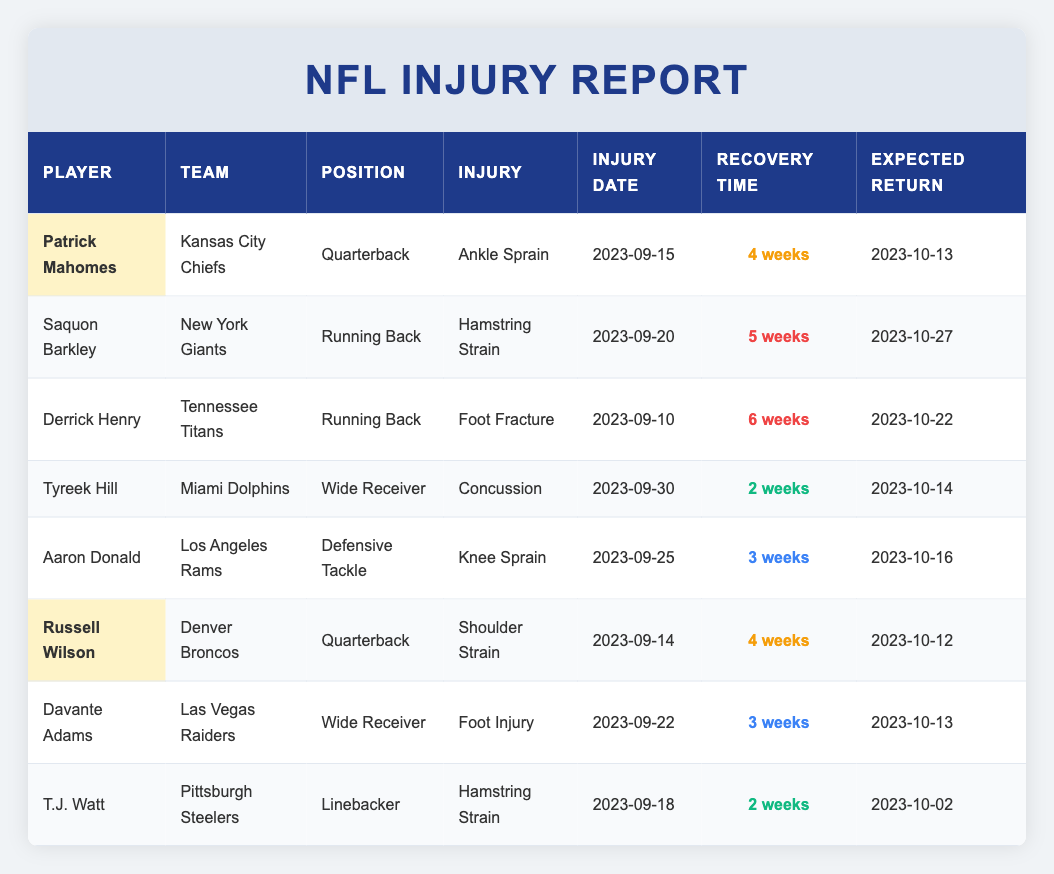What is the expected return date for Patrick Mahomes? The table shows that the expected return date for Patrick Mahomes, who has an ankle sprain, is listed as 2023-10-13.
Answer: 2023-10-13 Which player has the longest recovery timeline? Derrick Henry's recovery time is listed as 6 weeks, which is the longest compared to other players in the table.
Answer: Derrick Henry Are there any players expected to return in less than 3 weeks? Yes, Tyreek Hill and T.J. Watt are expected to return in 2 weeks, which is less than 3 weeks, as indicated in the recovery time column.
Answer: Yes How many players are quarterbacks and what are their recovery times? There are two quarterbacks: Patrick Mahomes with a recovery time of 4 weeks and Russell Wilson also with a recovery time of 4 weeks, as seen in their respective rows.
Answer: 2 players, 4 weeks each What injury did Saquon Barkley sustain, and when is he expected to return? The table indicates that Saquon Barkley sustained a hamstring strain and is expected to return on 2023-10-27, which can be found in his row.
Answer: Hamstring strain, 2023-10-27 Which player is expected to return first, and when? T.J. Watt is expected to return first on 2023-10-02, which is the earliest date listed in the expected return column.
Answer: T.J. Watt on 2023-10-02 Is there any player returning on the same day as Patrick Mahomes? Yes, Davante Adams is also expected to return on 2023-10-13, the same day as Patrick Mahomes, as seen in the expected return column.
Answer: Yes What is the average recovery time for all players listed? To find the average, sum the recovery times (4 + 5 + 6 + 2 + 3 + 4 + 3 + 2 = 29 weeks) and divide by the number of players (8). So, 29 / 8 = 3.625 weeks.
Answer: 3.625 weeks How many players are listed with a knee injury and what is their expected return date? The only player listed with a knee injury is Aaron Donald, with an expected return date of 2023-10-16, as shown in his row.
Answer: Aaron Donald, 2023-10-16 Was there a player on this list who had an injury prior to September 15, 2023? Yes, Derrick Henry's injury occurred on September 10, 2023, which is before September 15, as can be seen in the injury date column.
Answer: Yes Which player is listed with a hamstring strain, and what is their recovery time? There are two players with a hamstring strain: Saquon Barkley with 5 weeks recovery time and T.J. Watt with 2 weeks recovery time, indicated in their respective rows.
Answer: Saquon Barkley: 5 weeks, T.J. Watt: 2 weeks 